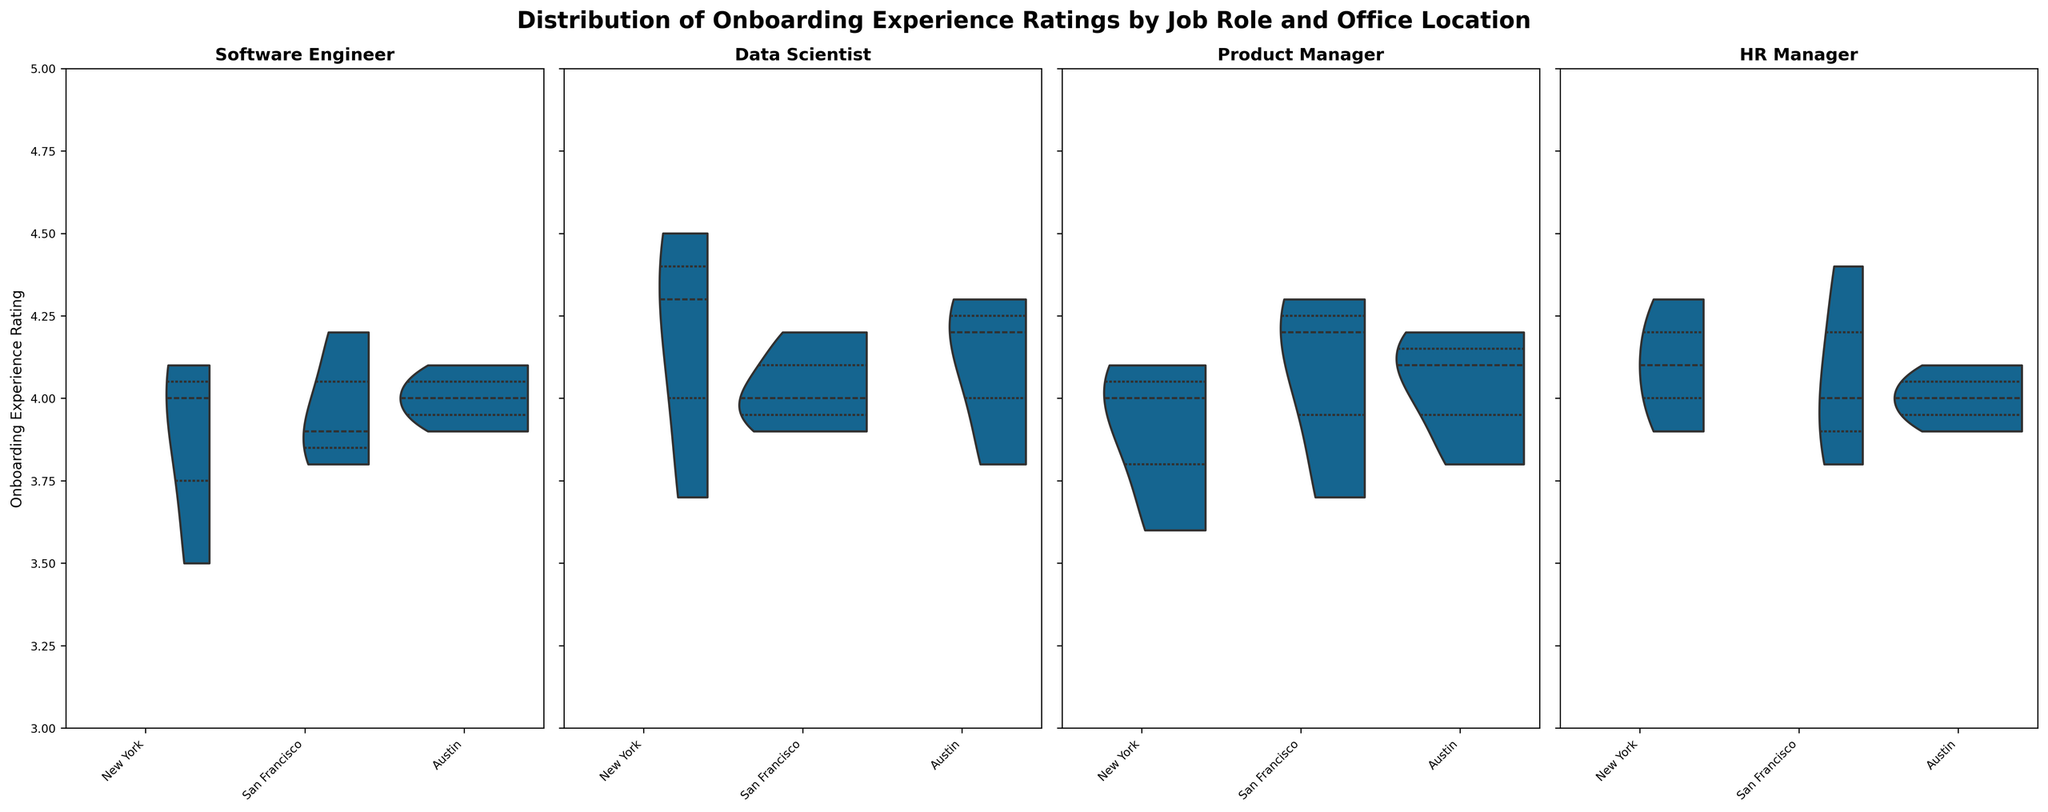what's the title of the figure? The title of the figure is prominently displayed at the top and is generally in bold to catch attention. It describes the main topic or focus of the plot.
Answer: Distribution of Onboarding Experience Ratings by Job Role and Office Location which job role has the highest average onboarding experience rating in San Francisco? To determine this, we need to look at the central tendency (mean) of the ratings for each job role's violin plot focusing on the San Francisco data. Observe the center 'bulge' of each violin split.
Answer: Product Manager what’s the spread of onboarding experience ratings for HR Managers in New York? The spread of the distribution can be observed from the width of the violin plot for HR Managers in New York. The wider the plot, the more spread out the ratings are.
Answer: 3.9 to 4.3 which job role shows the greatest variance in onboarding experience ratings across all locations? To find the highest variance, compare the shapes of the violins for each job role. The one with the widest distribution across all locations indicates the greatest variance.
Answer: Product Manager compare the median onboarding experience rating for Data Scientists in New York and Austin. Look at the thick central line within the violin plot for Data Scientists in both New York and Austin. The median is represented by this line.
Answer: New York: 4.3, Austin: 4.1 which location has the most consistent onboarding experience ratings for Software Engineers? Consistency in the ratings can be interpreted from the narrowness of the violin plot. The location with the narrowest plot for Software Engineers shows the most consistency.
Answer: Austin do Software Engineers in San Francisco have a higher median rating than in Austin? Compare the central line of the violin plots for Software Engineers in San Francisco and Austin. The median is represented by this line.
Answer: Yes how do the onboarding experience ratings for Product Managers in New York compare to those in San Francisco? Look at the violin plots for Product Managers in both New York and San Francisco. Compare the central tendency and spread of both distributions.
Answer: New York has a slightly lower central tendency and smaller spread compared to San Francisco is the spread of ratings broader for HR Managers in Austin or San Francisco? Compare the width of the violin plots for HR Managers in both Austin and San Francisco. The broader the plot, the larger the spread.
Answer: San Francisco does any job role have a median onboarding experience rating below 4.0 in any location? Look at the central lines within the violin plots. The median rating below 4.0 will be observed as below the middle point in the plot.
Answer: Yes, Software Engineers in New York and San Francisco 